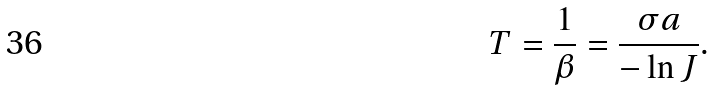Convert formula to latex. <formula><loc_0><loc_0><loc_500><loc_500>T = \frac { 1 } { \beta } = \frac { \sigma a } { - \ln J } .</formula> 